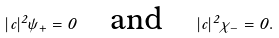Convert formula to latex. <formula><loc_0><loc_0><loc_500><loc_500>| c | ^ { 2 } \psi _ { + } = 0 \quad \text {and} \quad | c | ^ { 2 } \chi _ { - } = 0 .</formula> 